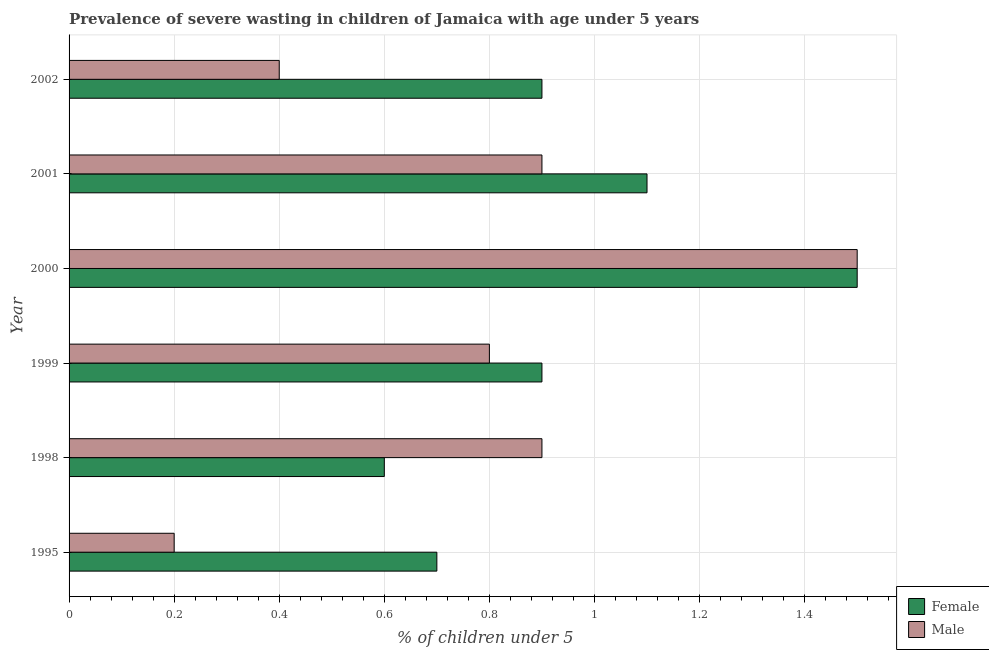How many bars are there on the 5th tick from the top?
Your response must be concise. 2. What is the percentage of undernourished female children in 2002?
Offer a terse response. 0.9. Across all years, what is the maximum percentage of undernourished female children?
Give a very brief answer. 1.5. Across all years, what is the minimum percentage of undernourished male children?
Offer a terse response. 0.2. In which year was the percentage of undernourished female children minimum?
Give a very brief answer. 1998. What is the total percentage of undernourished male children in the graph?
Offer a terse response. 4.7. What is the difference between the percentage of undernourished male children in 2000 and the percentage of undernourished female children in 1995?
Your answer should be very brief. 0.8. What is the average percentage of undernourished male children per year?
Offer a terse response. 0.78. In the year 2002, what is the difference between the percentage of undernourished male children and percentage of undernourished female children?
Provide a succinct answer. -0.5. What is the ratio of the percentage of undernourished male children in 1998 to that in 2002?
Provide a short and direct response. 2.25. Is the difference between the percentage of undernourished female children in 1998 and 2002 greater than the difference between the percentage of undernourished male children in 1998 and 2002?
Provide a short and direct response. No. Is the sum of the percentage of undernourished female children in 1999 and 2000 greater than the maximum percentage of undernourished male children across all years?
Provide a succinct answer. Yes. What does the 2nd bar from the top in 1999 represents?
Provide a short and direct response. Female. What does the 2nd bar from the bottom in 1995 represents?
Offer a terse response. Male. Are all the bars in the graph horizontal?
Your answer should be very brief. Yes. How many years are there in the graph?
Provide a succinct answer. 6. Does the graph contain any zero values?
Offer a terse response. No. How are the legend labels stacked?
Keep it short and to the point. Vertical. What is the title of the graph?
Keep it short and to the point. Prevalence of severe wasting in children of Jamaica with age under 5 years. What is the label or title of the X-axis?
Your answer should be compact.  % of children under 5. What is the label or title of the Y-axis?
Keep it short and to the point. Year. What is the  % of children under 5 of Female in 1995?
Offer a very short reply. 0.7. What is the  % of children under 5 of Male in 1995?
Provide a succinct answer. 0.2. What is the  % of children under 5 of Female in 1998?
Your answer should be compact. 0.6. What is the  % of children under 5 in Male in 1998?
Your answer should be very brief. 0.9. What is the  % of children under 5 in Female in 1999?
Ensure brevity in your answer.  0.9. What is the  % of children under 5 in Male in 1999?
Keep it short and to the point. 0.8. What is the  % of children under 5 in Female in 2000?
Make the answer very short. 1.5. What is the  % of children under 5 of Female in 2001?
Offer a terse response. 1.1. What is the  % of children under 5 in Male in 2001?
Ensure brevity in your answer.  0.9. What is the  % of children under 5 in Female in 2002?
Provide a short and direct response. 0.9. What is the  % of children under 5 of Male in 2002?
Keep it short and to the point. 0.4. Across all years, what is the maximum  % of children under 5 of Female?
Your response must be concise. 1.5. Across all years, what is the minimum  % of children under 5 in Female?
Your response must be concise. 0.6. Across all years, what is the minimum  % of children under 5 in Male?
Give a very brief answer. 0.2. What is the total  % of children under 5 of Female in the graph?
Provide a short and direct response. 5.7. What is the total  % of children under 5 in Male in the graph?
Keep it short and to the point. 4.7. What is the difference between the  % of children under 5 of Female in 1995 and that in 1998?
Offer a very short reply. 0.1. What is the difference between the  % of children under 5 of Male in 1995 and that in 1998?
Provide a short and direct response. -0.7. What is the difference between the  % of children under 5 of Female in 1995 and that in 1999?
Your answer should be compact. -0.2. What is the difference between the  % of children under 5 of Male in 1995 and that in 1999?
Give a very brief answer. -0.6. What is the difference between the  % of children under 5 in Female in 1995 and that in 2000?
Your answer should be compact. -0.8. What is the difference between the  % of children under 5 in Male in 1995 and that in 2000?
Offer a very short reply. -1.3. What is the difference between the  % of children under 5 in Female in 1995 and that in 2001?
Ensure brevity in your answer.  -0.4. What is the difference between the  % of children under 5 of Male in 1995 and that in 2001?
Offer a terse response. -0.7. What is the difference between the  % of children under 5 of Male in 1998 and that in 1999?
Ensure brevity in your answer.  0.1. What is the difference between the  % of children under 5 of Female in 1998 and that in 2000?
Your answer should be compact. -0.9. What is the difference between the  % of children under 5 of Male in 1998 and that in 2000?
Give a very brief answer. -0.6. What is the difference between the  % of children under 5 in Female in 1998 and that in 2001?
Ensure brevity in your answer.  -0.5. What is the difference between the  % of children under 5 in Male in 1998 and that in 2002?
Your response must be concise. 0.5. What is the difference between the  % of children under 5 of Female in 1999 and that in 2000?
Offer a terse response. -0.6. What is the difference between the  % of children under 5 of Female in 1999 and that in 2001?
Offer a terse response. -0.2. What is the difference between the  % of children under 5 in Male in 1999 and that in 2002?
Your answer should be compact. 0.4. What is the difference between the  % of children under 5 of Male in 2000 and that in 2001?
Offer a terse response. 0.6. What is the difference between the  % of children under 5 of Female in 2000 and that in 2002?
Provide a short and direct response. 0.6. What is the difference between the  % of children under 5 in Male in 2000 and that in 2002?
Give a very brief answer. 1.1. What is the difference between the  % of children under 5 of Female in 2001 and that in 2002?
Ensure brevity in your answer.  0.2. What is the difference between the  % of children under 5 in Female in 1995 and the  % of children under 5 in Male in 1998?
Keep it short and to the point. -0.2. What is the difference between the  % of children under 5 in Female in 1995 and the  % of children under 5 in Male in 1999?
Your response must be concise. -0.1. What is the difference between the  % of children under 5 in Female in 1995 and the  % of children under 5 in Male in 2001?
Give a very brief answer. -0.2. What is the difference between the  % of children under 5 in Female in 1995 and the  % of children under 5 in Male in 2002?
Your response must be concise. 0.3. What is the difference between the  % of children under 5 of Female in 1999 and the  % of children under 5 of Male in 2002?
Provide a succinct answer. 0.5. What is the average  % of children under 5 in Female per year?
Keep it short and to the point. 0.95. What is the average  % of children under 5 in Male per year?
Your response must be concise. 0.78. In the year 1998, what is the difference between the  % of children under 5 in Female and  % of children under 5 in Male?
Keep it short and to the point. -0.3. In the year 2001, what is the difference between the  % of children under 5 of Female and  % of children under 5 of Male?
Keep it short and to the point. 0.2. In the year 2002, what is the difference between the  % of children under 5 of Female and  % of children under 5 of Male?
Give a very brief answer. 0.5. What is the ratio of the  % of children under 5 of Female in 1995 to that in 1998?
Keep it short and to the point. 1.17. What is the ratio of the  % of children under 5 in Male in 1995 to that in 1998?
Make the answer very short. 0.22. What is the ratio of the  % of children under 5 of Male in 1995 to that in 1999?
Offer a very short reply. 0.25. What is the ratio of the  % of children under 5 in Female in 1995 to that in 2000?
Your answer should be compact. 0.47. What is the ratio of the  % of children under 5 of Male in 1995 to that in 2000?
Your answer should be compact. 0.13. What is the ratio of the  % of children under 5 of Female in 1995 to that in 2001?
Your answer should be very brief. 0.64. What is the ratio of the  % of children under 5 of Male in 1995 to that in 2001?
Your response must be concise. 0.22. What is the ratio of the  % of children under 5 in Female in 1995 to that in 2002?
Your answer should be compact. 0.78. What is the ratio of the  % of children under 5 in Male in 1998 to that in 1999?
Offer a terse response. 1.12. What is the ratio of the  % of children under 5 of Female in 1998 to that in 2001?
Provide a short and direct response. 0.55. What is the ratio of the  % of children under 5 of Male in 1998 to that in 2001?
Offer a very short reply. 1. What is the ratio of the  % of children under 5 in Male in 1998 to that in 2002?
Make the answer very short. 2.25. What is the ratio of the  % of children under 5 of Female in 1999 to that in 2000?
Provide a succinct answer. 0.6. What is the ratio of the  % of children under 5 of Male in 1999 to that in 2000?
Give a very brief answer. 0.53. What is the ratio of the  % of children under 5 of Female in 1999 to that in 2001?
Make the answer very short. 0.82. What is the ratio of the  % of children under 5 in Male in 1999 to that in 2001?
Provide a succinct answer. 0.89. What is the ratio of the  % of children under 5 in Female in 2000 to that in 2001?
Provide a succinct answer. 1.36. What is the ratio of the  % of children under 5 in Male in 2000 to that in 2001?
Offer a very short reply. 1.67. What is the ratio of the  % of children under 5 of Female in 2000 to that in 2002?
Your response must be concise. 1.67. What is the ratio of the  % of children under 5 of Male in 2000 to that in 2002?
Provide a succinct answer. 3.75. What is the ratio of the  % of children under 5 in Female in 2001 to that in 2002?
Offer a very short reply. 1.22. What is the ratio of the  % of children under 5 of Male in 2001 to that in 2002?
Your response must be concise. 2.25. What is the difference between the highest and the second highest  % of children under 5 in Male?
Offer a very short reply. 0.6. 